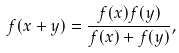<formula> <loc_0><loc_0><loc_500><loc_500>f ( x + y ) = \frac { f ( x ) f ( y ) } { f ( x ) + f ( y ) } ,</formula> 